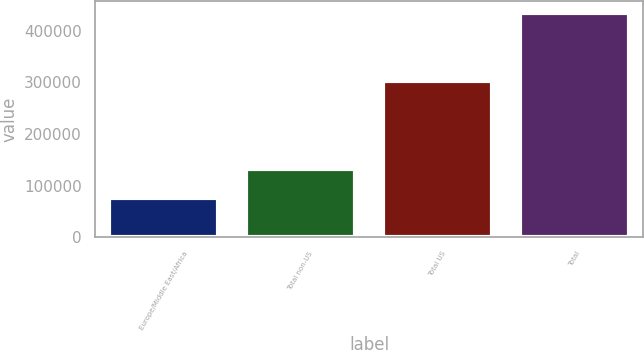Convert chart. <chart><loc_0><loc_0><loc_500><loc_500><bar_chart><fcel>Europe/Middle East/Africa<fcel>Total non-US<fcel>Total US<fcel>Total<nl><fcel>75706<fcel>132716<fcel>302098<fcel>434814<nl></chart> 